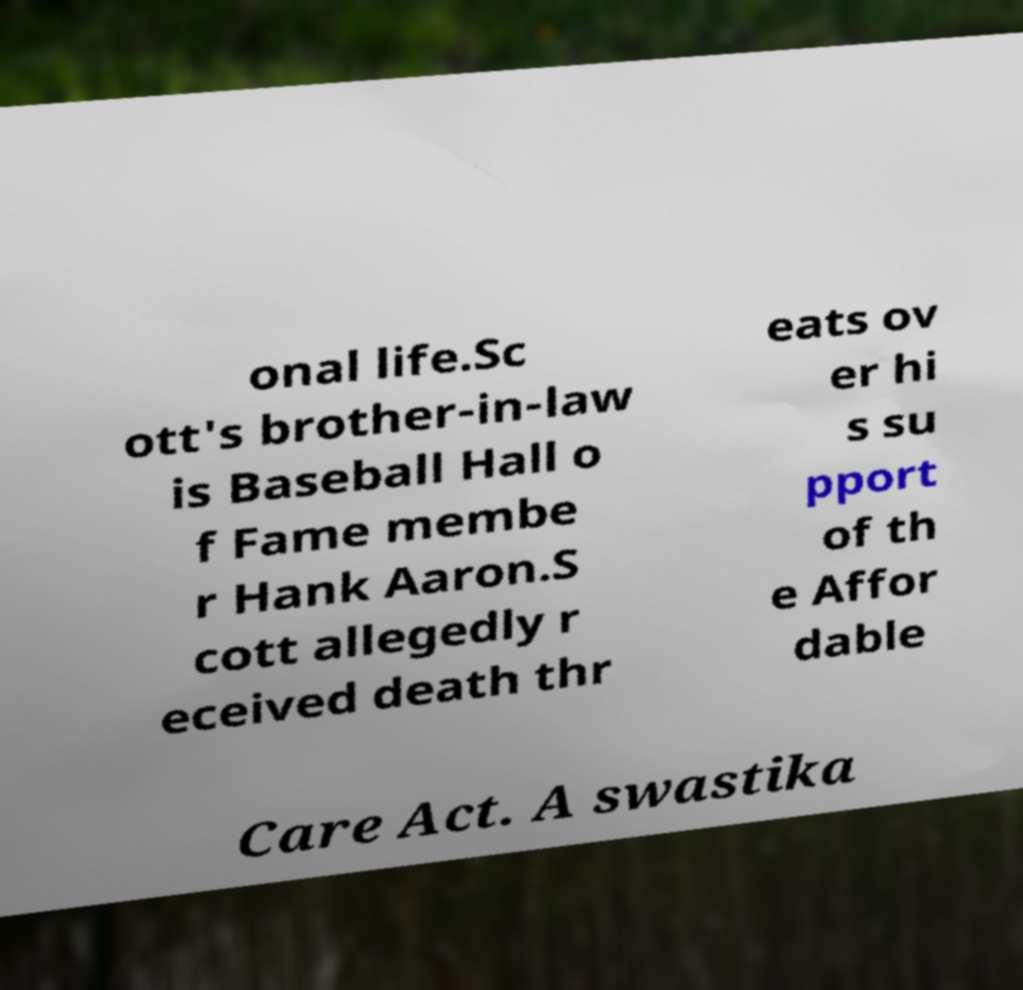What messages or text are displayed in this image? I need them in a readable, typed format. onal life.Sc ott's brother-in-law is Baseball Hall o f Fame membe r Hank Aaron.S cott allegedly r eceived death thr eats ov er hi s su pport of th e Affor dable Care Act. A swastika 